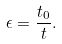<formula> <loc_0><loc_0><loc_500><loc_500>\epsilon = \frac { t _ { 0 } } { t } .</formula> 